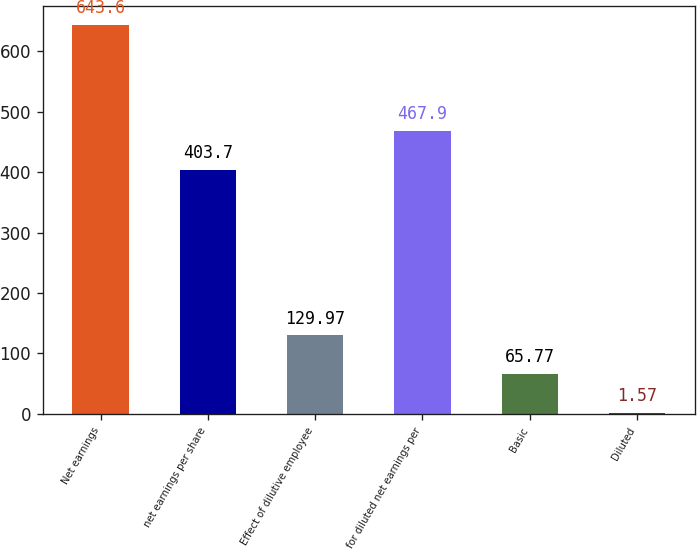Convert chart to OTSL. <chart><loc_0><loc_0><loc_500><loc_500><bar_chart><fcel>Net earnings<fcel>net earnings per share<fcel>Effect of dilutive employee<fcel>for diluted net earnings per<fcel>Basic<fcel>Diluted<nl><fcel>643.6<fcel>403.7<fcel>129.97<fcel>467.9<fcel>65.77<fcel>1.57<nl></chart> 